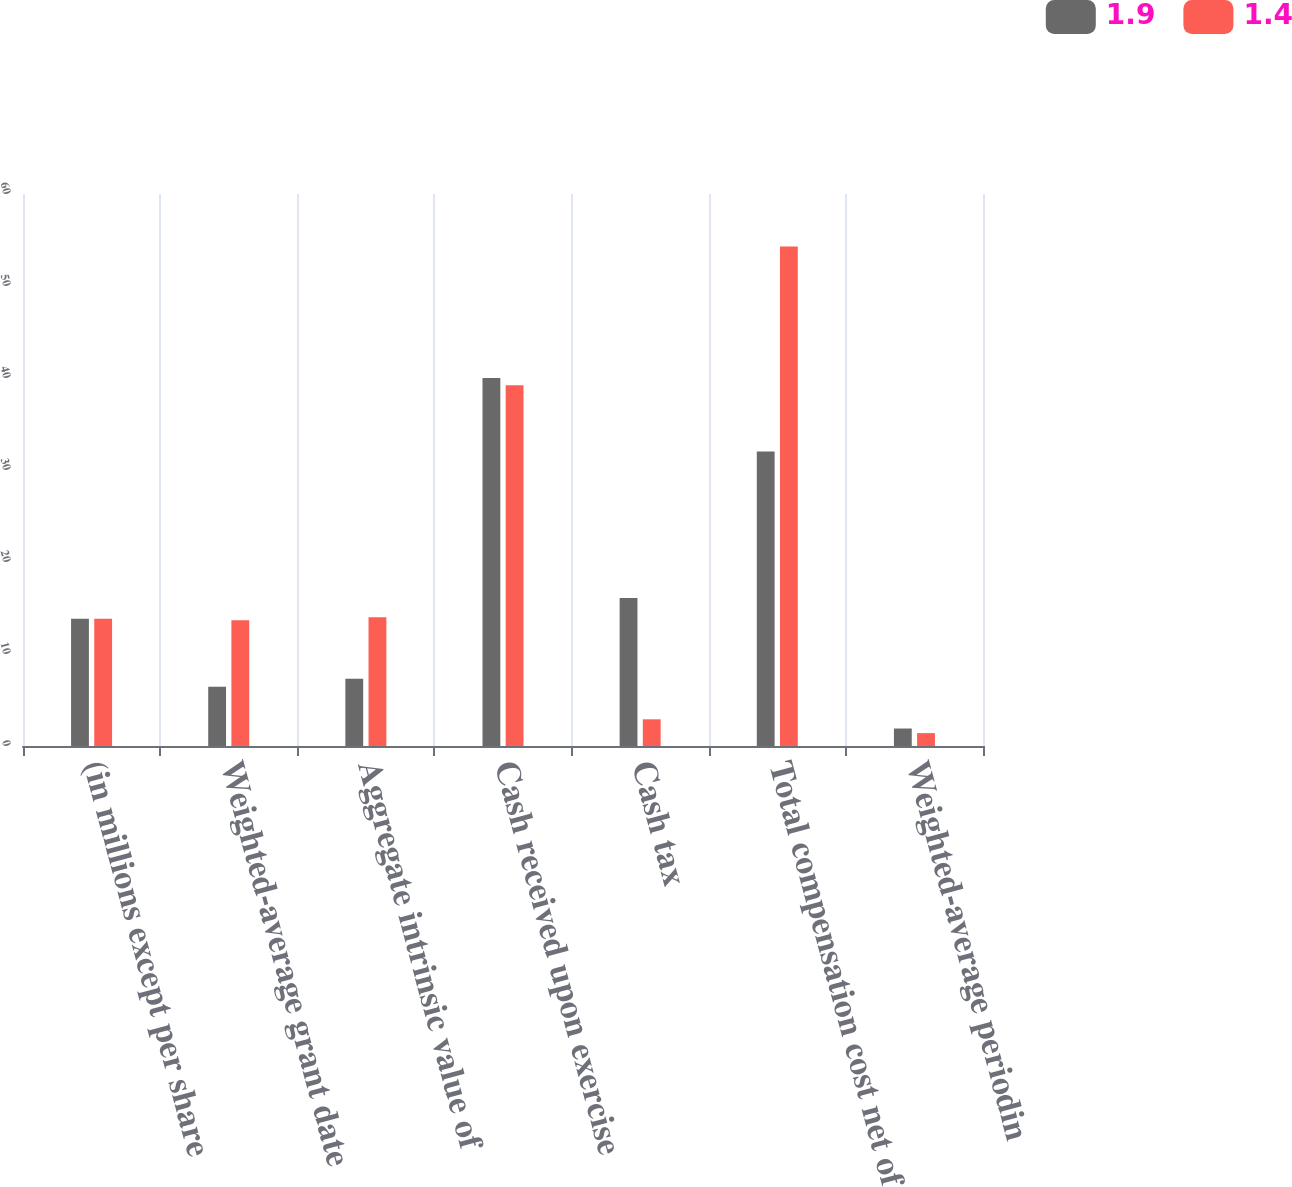<chart> <loc_0><loc_0><loc_500><loc_500><stacked_bar_chart><ecel><fcel>(in millions except per share<fcel>Weighted-average grant date<fcel>Aggregate intrinsic value of<fcel>Cash received upon exercise<fcel>Cash tax<fcel>Total compensation cost net of<fcel>Weighted-average periodin<nl><fcel>1.9<fcel>13.835<fcel>6.44<fcel>7.3<fcel>40<fcel>16.1<fcel>32<fcel>1.9<nl><fcel>1.4<fcel>13.835<fcel>13.67<fcel>14<fcel>39.2<fcel>2.9<fcel>54.3<fcel>1.4<nl></chart> 